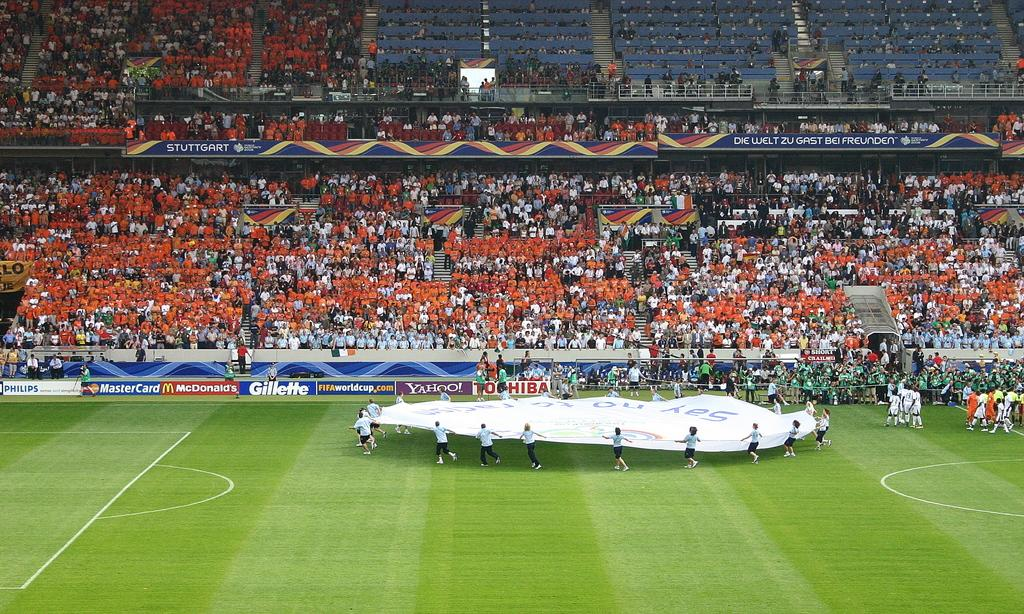<image>
Provide a brief description of the given image. A group of people dragging a circular item towards a Gillette sign. 